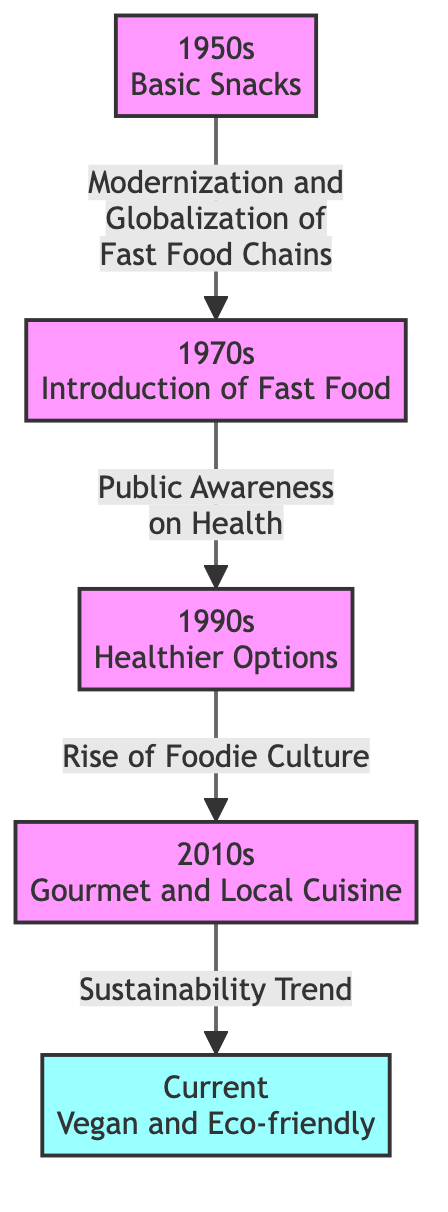What food option was available in the 1950s? The diagram indicates that the food option available in the 1950s was "Basic Snacks." This is explicitly mentioned in the node labeled "1950s."
Answer: Basic Snacks What decade saw the introduction of fast food? According to the diagram, the introduction of fast food occurred in the 1970s, as represented in the node labeled "1970s."
Answer: 1970s How many nodes are present in the diagram? The diagram has a total of five nodes representing different decades and types of food offerings. Each decade is represented as a separate node.
Answer: 5 What prompted the shift from fast food to healthier options? The flow from “1970s” to “1990s” indicates that the shift from fast food to healthier options was prompted by "Public Awareness on Health," which is the label on the connecting edge.
Answer: Public Awareness on Health What food trend began in the 2010s? The diagram shows that the food trend that began in the 2010s was "Gourmet and Local Cuisine," which is indicated in the corresponding node.
Answer: Gourmet and Local Cuisine Which decade is linked to the sustainability trend? The diagram reflects that the sustainability trend is linked to the current food options, specifically connecting the “2010s” node to the “Current” node, showing the evolution of offerings over time.
Answer: Current What type of cuisine is emphasized in the current food offerings? The current food offerings are emphasized as "Vegan and Eco-friendly," as clearly stated in the node labeled "Current."
Answer: Vegan and Eco-friendly What was the main cultural influence on the food offerings in the 2010s? The rise of "Foodie Culture" is noted as the main cultural influence on food offerings that emerged in the 2010s, connecting it to the gourmet and local options.
Answer: Foodie Culture What connection do the 1990s and 2010s have in terms of food evolution? The connection between the 1990s and the 2010s shows a progression in food trends where the earlier health-conscious options in the 1990s lead to the more diverse gourmet offerings in the 2010s, linked by the rise of food culture.
Answer: Rise of Foodie Culture 